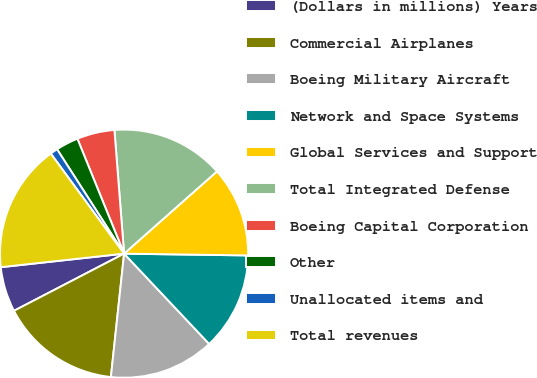<chart> <loc_0><loc_0><loc_500><loc_500><pie_chart><fcel>(Dollars in millions) Years<fcel>Commercial Airplanes<fcel>Boeing Military Aircraft<fcel>Network and Space Systems<fcel>Global Services and Support<fcel>Total Integrated Defense<fcel>Boeing Capital Corporation<fcel>Other<fcel>Unallocated items and<fcel>Total revenues<nl><fcel>5.88%<fcel>15.68%<fcel>13.72%<fcel>12.74%<fcel>11.76%<fcel>14.7%<fcel>4.9%<fcel>2.94%<fcel>0.98%<fcel>16.67%<nl></chart> 